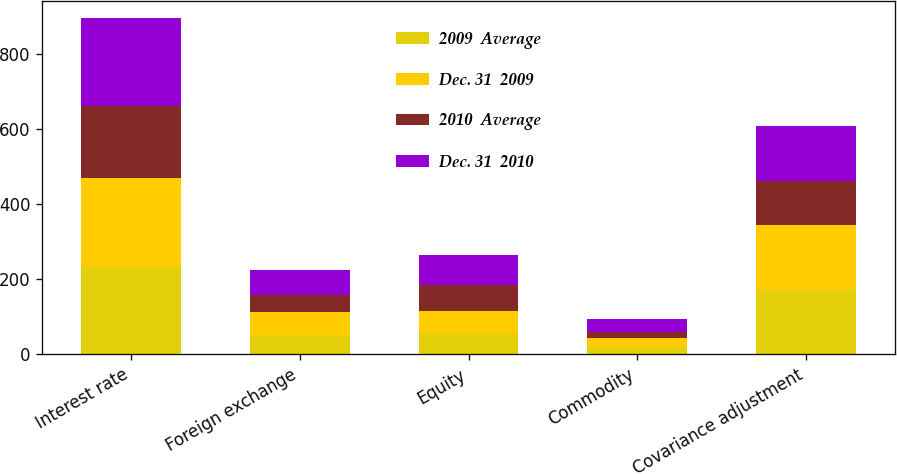Convert chart. <chart><loc_0><loc_0><loc_500><loc_500><stacked_bar_chart><ecel><fcel>Interest rate<fcel>Foreign exchange<fcel>Equity<fcel>Commodity<fcel>Covariance adjustment<nl><fcel>2009  Average<fcel>235<fcel>52<fcel>56<fcel>19<fcel>171<nl><fcel>Dec. 31  2009<fcel>234<fcel>61<fcel>59<fcel>23<fcel>172<nl><fcel>2010  Average<fcel>191<fcel>45<fcel>69<fcel>18<fcel>118<nl><fcel>Dec. 31  2010<fcel>235<fcel>65<fcel>79<fcel>34<fcel>147<nl></chart> 